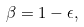<formula> <loc_0><loc_0><loc_500><loc_500>\beta = 1 - \epsilon ,</formula> 